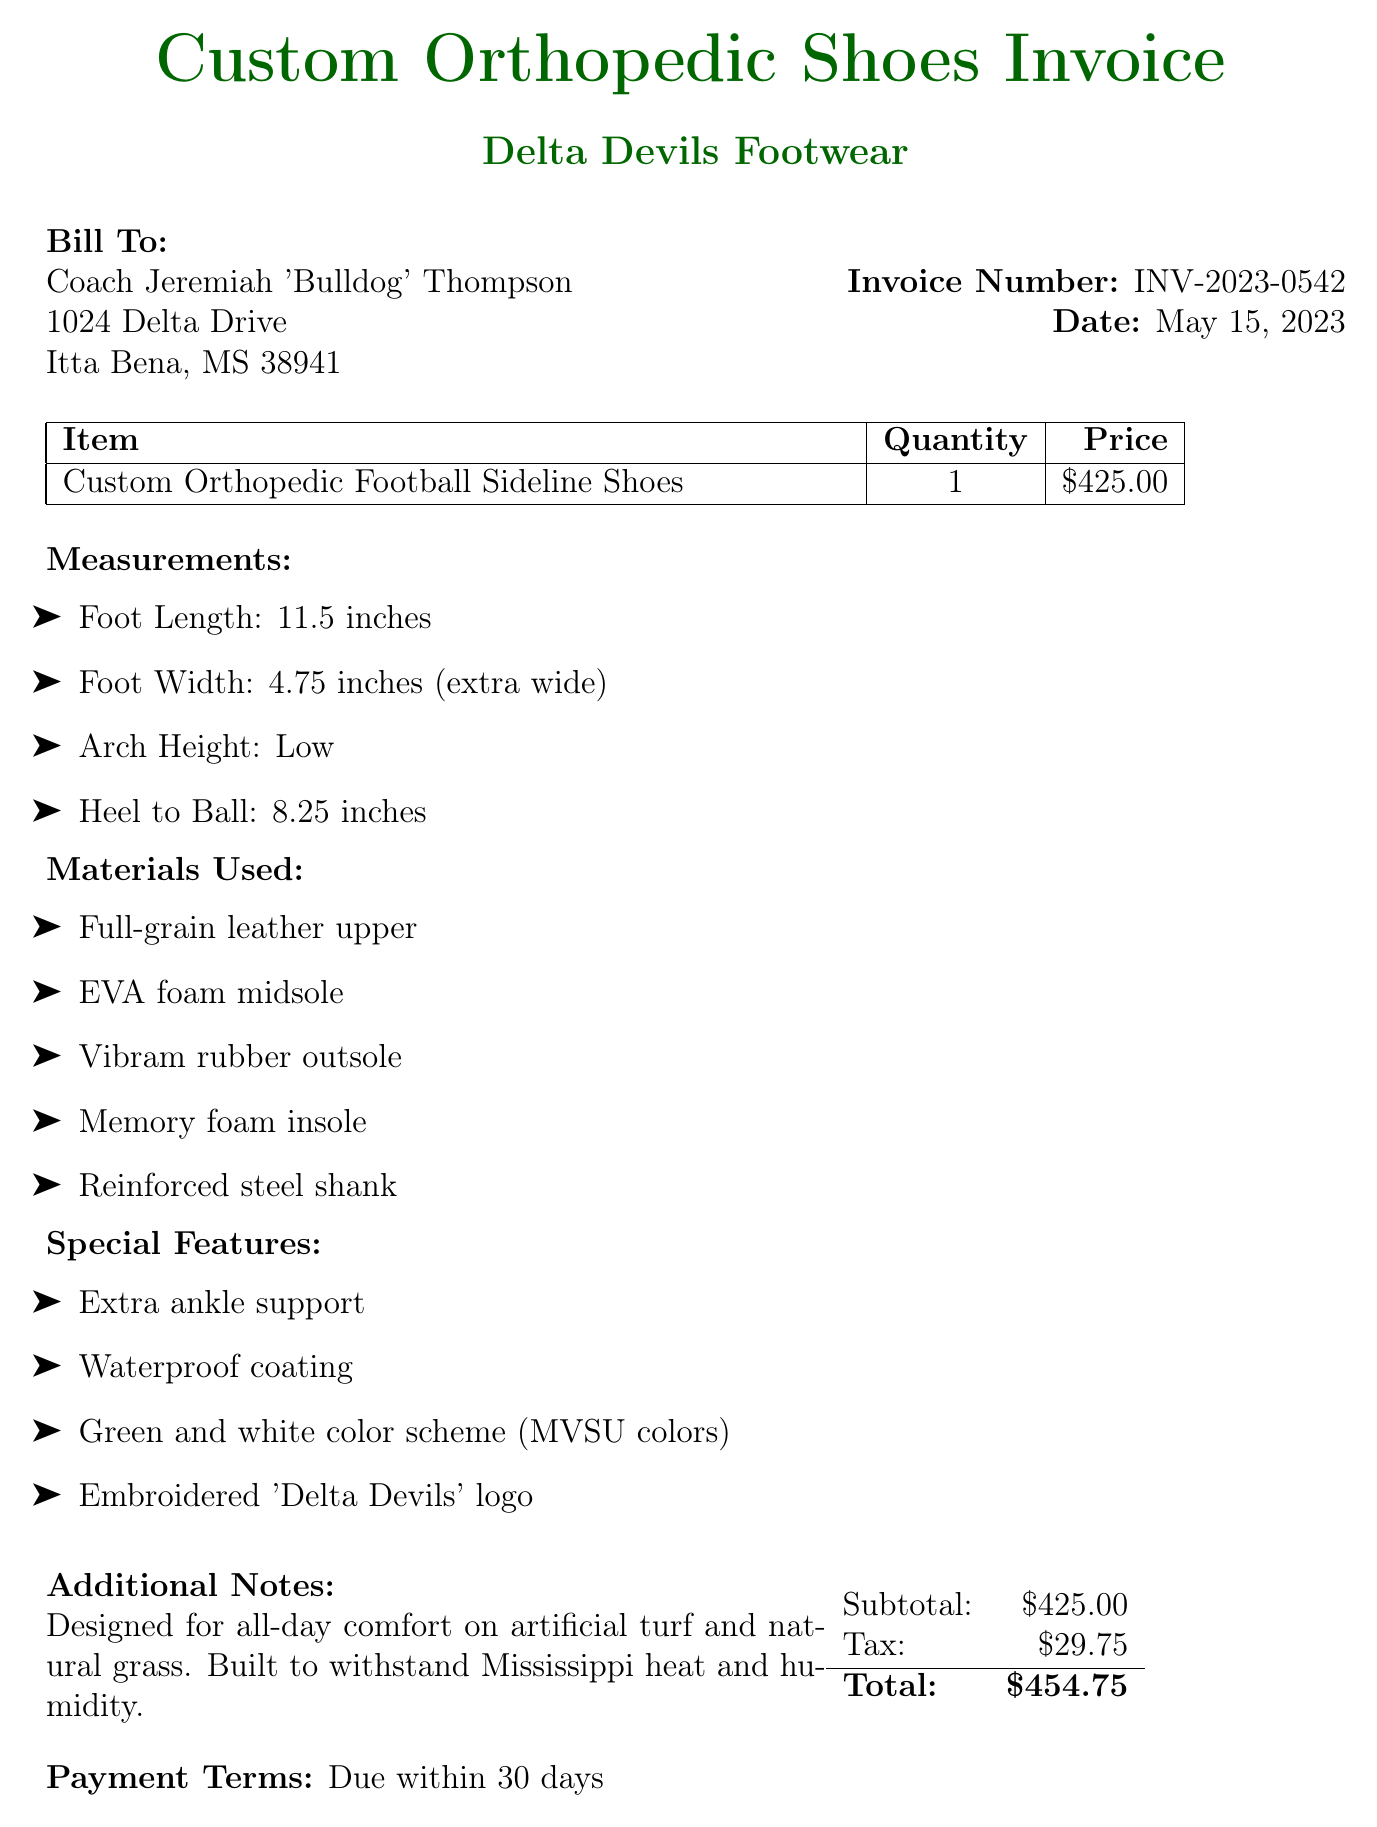What is the invoice number? The invoice number is listed in the document, which is INV-2023-0542.
Answer: INV-2023-0542 What is the total amount due? The total amount due is calculated from the subtotal and tax provided in the document, which sums up to $454.75.
Answer: $454.75 What are the measurements for Foot Width? The foot width measurement is specified in the document as 4.75 inches (extra wide).
Answer: 4.75 inches (extra wide) Who is the bill addressed to? The bill contains the name of the person it is addressed to, which is Coach Jeremiah 'Bulldog' Thompson.
Answer: Coach Jeremiah 'Bulldog' Thompson What is the payment term? The payment terms are stated in the document as due within 30 days.
Answer: Due within 30 days How much tax was added? The document indicates the tax added to the subtotal, which amounts to $29.75.
Answer: $29.75 What color scheme is used for the shoes? The document describes the color scheme for the shoes as green and white (MVSU colors).
Answer: Green and white color scheme (MVSU colors) What material is used for the outsole? The document specifies that the outsole is made of Vibram rubber.
Answer: Vibram rubber outsole What special feature provides ankle support? The document lists "extra ankle support" as one of the special features provided for the shoes.
Answer: Extra ankle support 